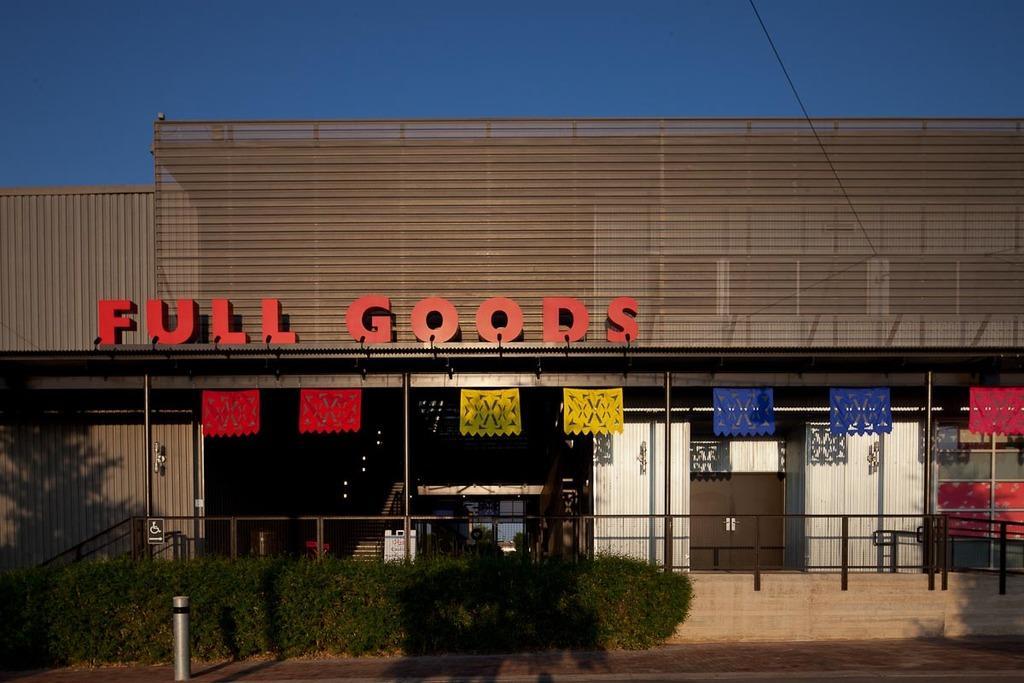Could you give a brief overview of what you see in this image? In the picture I can see shrubs, steel railing, a building, name board which is in red color and the blue color sky in the background. 